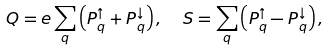<formula> <loc_0><loc_0><loc_500><loc_500>Q = e \sum _ { q } \left ( P ^ { \uparrow } _ { q } + P ^ { \downarrow } _ { q } \right ) , \ \ S = \sum _ { q } \left ( P ^ { \uparrow } _ { q } - P ^ { \downarrow } _ { q } \right ) ,</formula> 